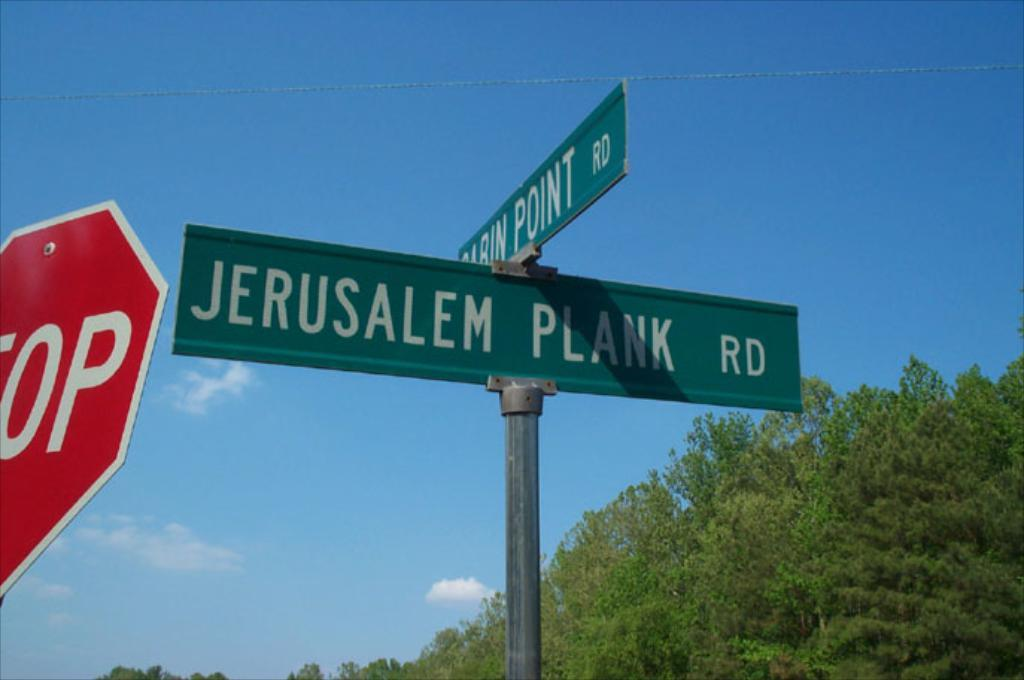<image>
Relay a brief, clear account of the picture shown. a stop sign is at the corner of Jerusalem plank road and something point road 